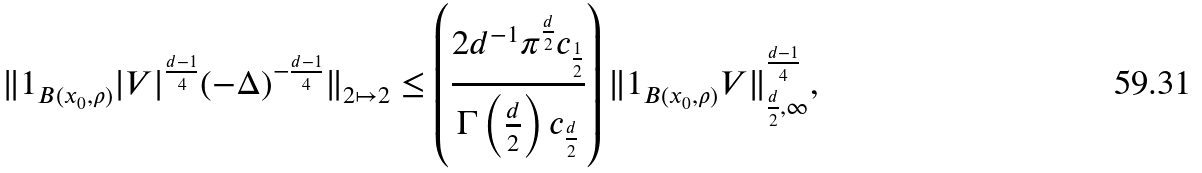Convert formula to latex. <formula><loc_0><loc_0><loc_500><loc_500>\| 1 _ { B ( x _ { 0 } , \rho ) } | V | ^ { \frac { d - 1 } { 4 } } ( - \Delta ) ^ { - \frac { d - 1 } { 4 } } \| _ { 2 \mapsto 2 } \leq \left ( \frac { 2 d ^ { - 1 } \pi ^ { \frac { d } { 2 } } c _ { \frac { 1 } { 2 } } } { \Gamma \left ( \frac { d } { 2 } \right ) c _ { \frac { d } { 2 } } } \right ) \| 1 _ { B ( x _ { 0 } , \rho ) } V \| _ { \frac { d } { 2 } , \infty } ^ { \frac { d - 1 } { 4 } } ,</formula> 